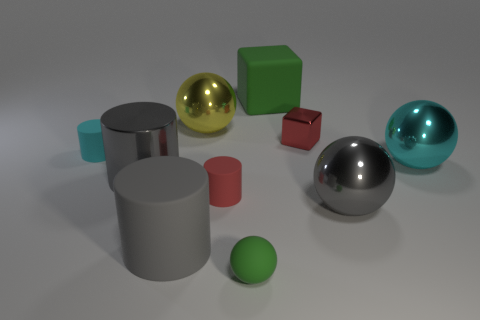How many rubber objects are the same color as the tiny shiny object?
Ensure brevity in your answer.  1. What is the shape of the red object that is made of the same material as the cyan ball?
Give a very brief answer. Cube. There is a metallic object on the left side of the large gray matte object; what is its size?
Keep it short and to the point. Large. Is the number of objects behind the large rubber cube the same as the number of green matte blocks that are behind the small red shiny object?
Give a very brief answer. No. There is a metal object behind the tiny red object that is behind the cyan object on the right side of the big green object; what is its color?
Your answer should be compact. Yellow. How many things are in front of the big yellow ball and on the left side of the small green thing?
Offer a very short reply. 4. There is a large rubber cube on the left side of the tiny red block; does it have the same color as the ball that is in front of the big gray rubber cylinder?
Ensure brevity in your answer.  Yes. There is a green rubber object that is the same shape as the red shiny object; what is its size?
Make the answer very short. Large. There is a tiny metal thing; are there any big metallic balls to the left of it?
Your response must be concise. Yes. Is the number of big cyan metal balls to the right of the cyan ball the same as the number of big gray metallic things?
Your answer should be compact. No. 